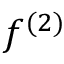Convert formula to latex. <formula><loc_0><loc_0><loc_500><loc_500>f ^ { ( 2 ) }</formula> 